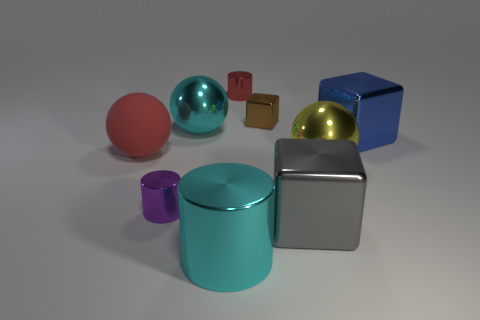Add 1 purple cylinders. How many objects exist? 10 Subtract all cylinders. How many objects are left? 6 Subtract all rubber spheres. Subtract all gray blocks. How many objects are left? 7 Add 2 tiny metal objects. How many tiny metal objects are left? 5 Add 9 large cyan shiny cylinders. How many large cyan shiny cylinders exist? 10 Subtract 1 cyan cylinders. How many objects are left? 8 